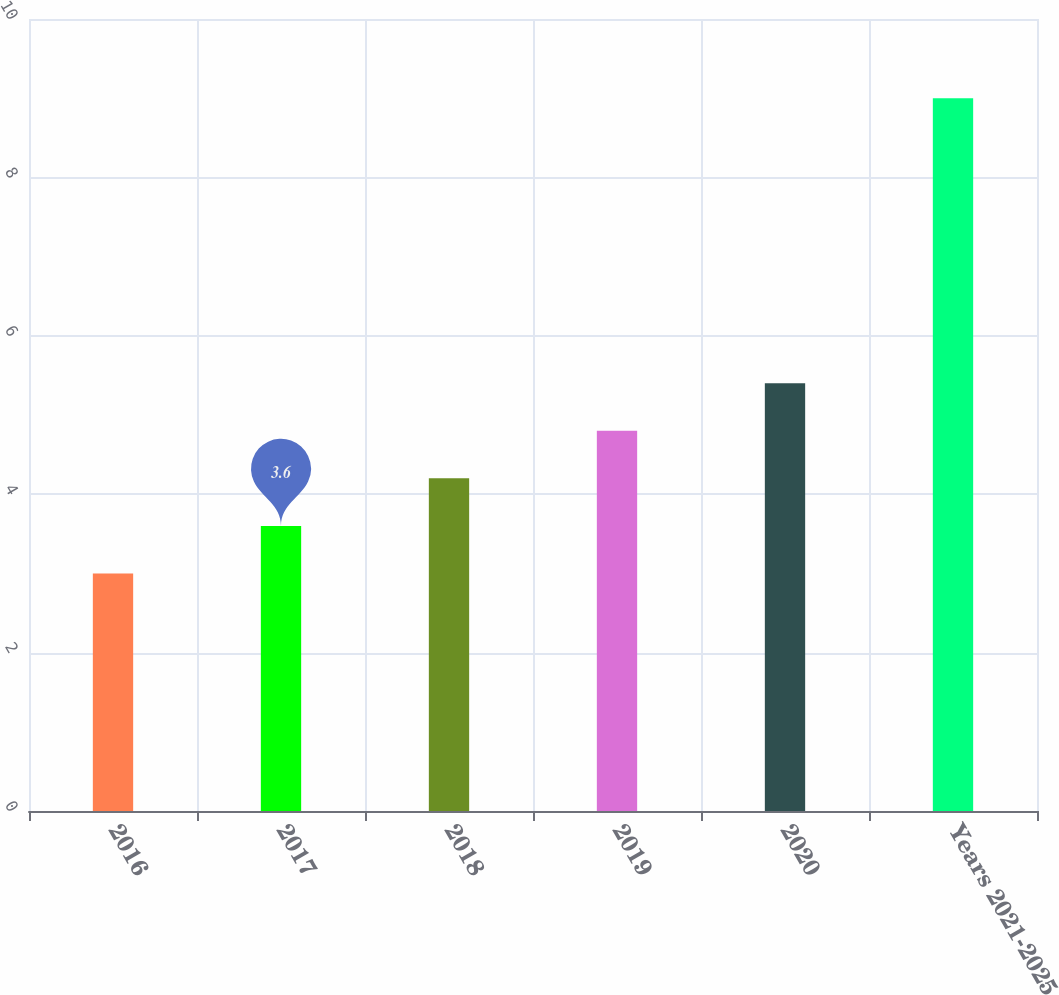<chart> <loc_0><loc_0><loc_500><loc_500><bar_chart><fcel>2016<fcel>2017<fcel>2018<fcel>2019<fcel>2020<fcel>Years 2021-­2025<nl><fcel>3<fcel>3.6<fcel>4.2<fcel>4.8<fcel>5.4<fcel>9<nl></chart> 